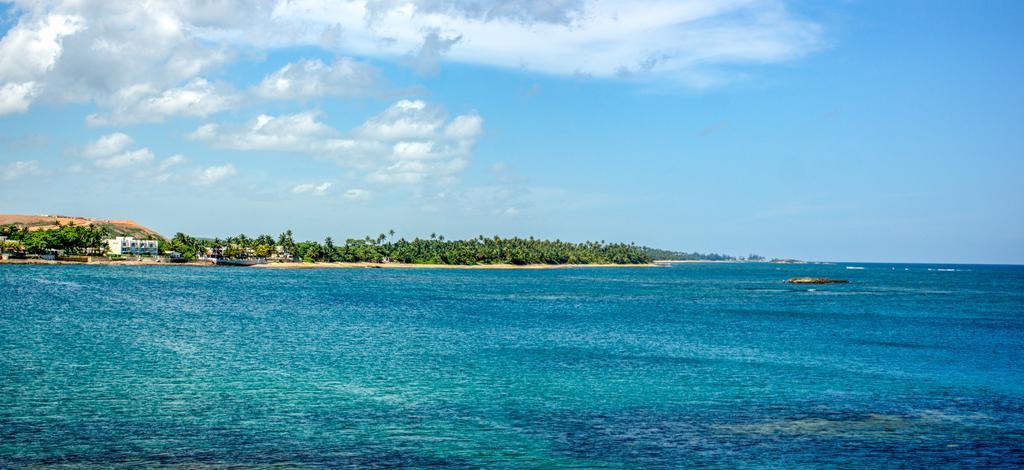In one or two sentences, can you explain what this image depicts? In this picture we can see water, in the background we can find few trees, buildings and clouds. 